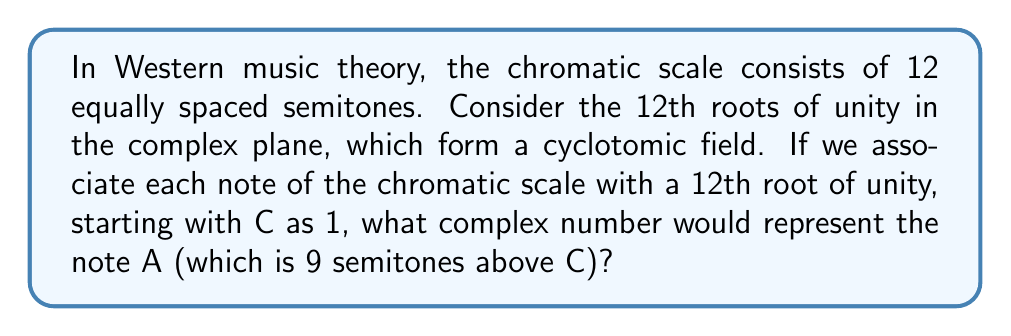Help me with this question. Let's approach this step-by-step:

1) The 12th roots of unity are given by the formula:
   $$e^{2\pi i k / 12}, \quad k = 0, 1, 2, ..., 11$$

2) These roots form a cyclotomic field, specifically the 12th cyclotomic field.

3) In our musical mapping:
   - C (0 semitones) corresponds to $k = 0$
   - C# (1 semitone) corresponds to $k = 1$
   - D (2 semitones) corresponds to $k = 2$
   ...and so on.

4) A is 9 semitones above C, so it corresponds to $k = 9$.

5) Substituting $k = 9$ into our formula:
   $$e^{2\pi i 9 / 12} = e^{3\pi i / 2}$$

6) We can simplify this further:
   $$e^{3\pi i / 2} = (e^{\pi i / 2})^3 = i^3 = -i$$

Therefore, in this cyclotomic representation of the chromatic scale, the note A is represented by the complex number $-i$.
Answer: $-i$ 